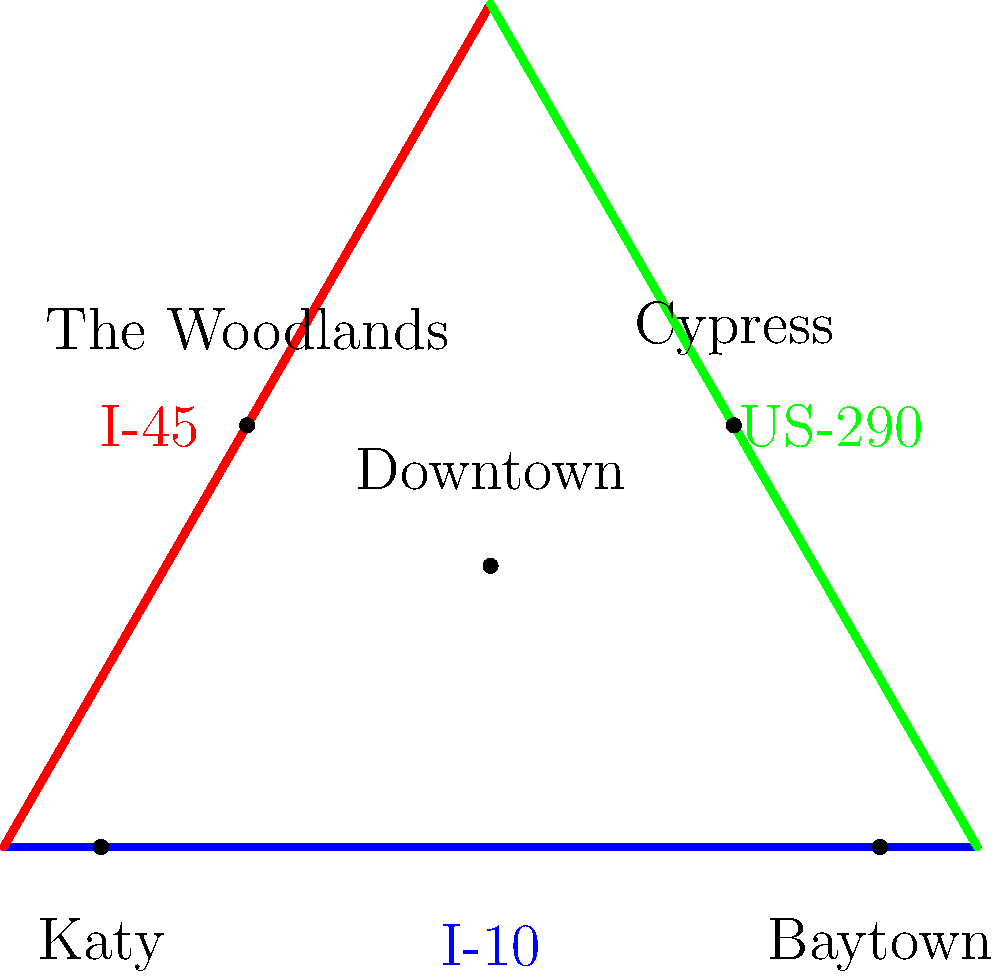In this simplified map of Houston's major highways, which highway forms the hypotenuse of the triangle created by I-10, I-45, and itself? To answer this question, let's break it down step-by-step:

1. Identify the highways on the map:
   - The blue horizontal line represents I-10
   - The red line on the left represents I-45
   - The green line on the right represents US-290

2. Recall the definition of a hypotenuse:
   - In a right-angled triangle, the hypotenuse is the longest side, opposite the right angle.

3. Analyze the triangle formed by the highways:
   - I-10 forms the base of the triangle
   - I-45 forms the left side of the triangle
   - US-290 forms the right side of the triangle

4. Determine which side is the longest:
   - Visually, we can see that US-290 appears to be the longest side of the triangle

5. Check if the triangle is right-angled:
   - The angle between I-10 and I-45 appears to be close to 90 degrees

6. Conclude:
   - Since US-290 is the longest side and is opposite the approximate right angle formed by I-10 and I-45, it must be the hypotenuse of the triangle

This simplified map reflects the general layout of Houston's highway system, where I-10 runs east-west, I-45 runs north-south, and US-290 connects the northwest suburbs to downtown, forming a rough triangle that's familiar to many Houston locals.
Answer: US-290 